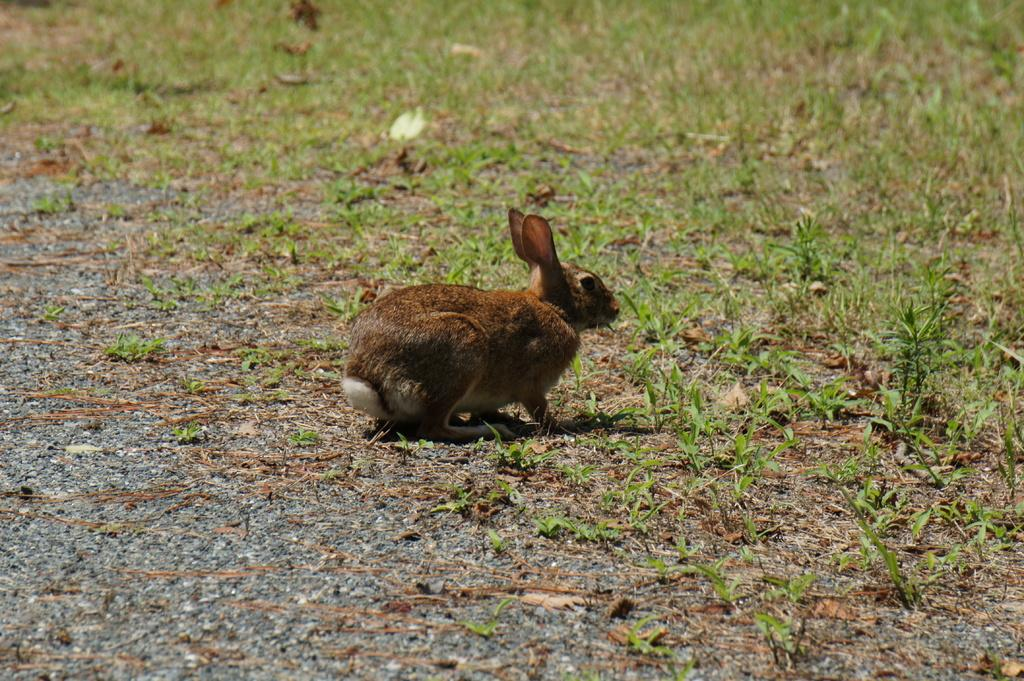What is the main subject of the picture? The main subject of the picture is a rabbit. Can you describe the rabbit's appearance? The rabbit is brown in color. What type of environment is visible in the image? There is grass visible on the ground in the image. What type of silver object is the rabbit using to fold its ears in the image? There is no silver object or folding of ears visible in the image; the rabbit is simply sitting on the grass. 